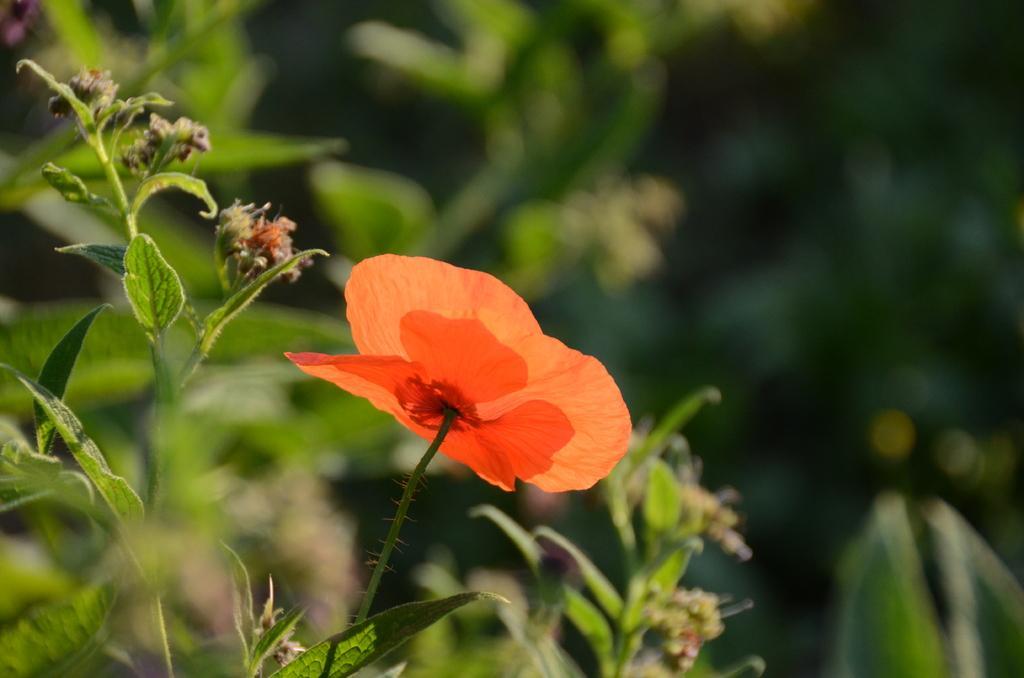Could you give a brief overview of what you see in this image? In this image we can see a flower to the plant and the background is blurred. 